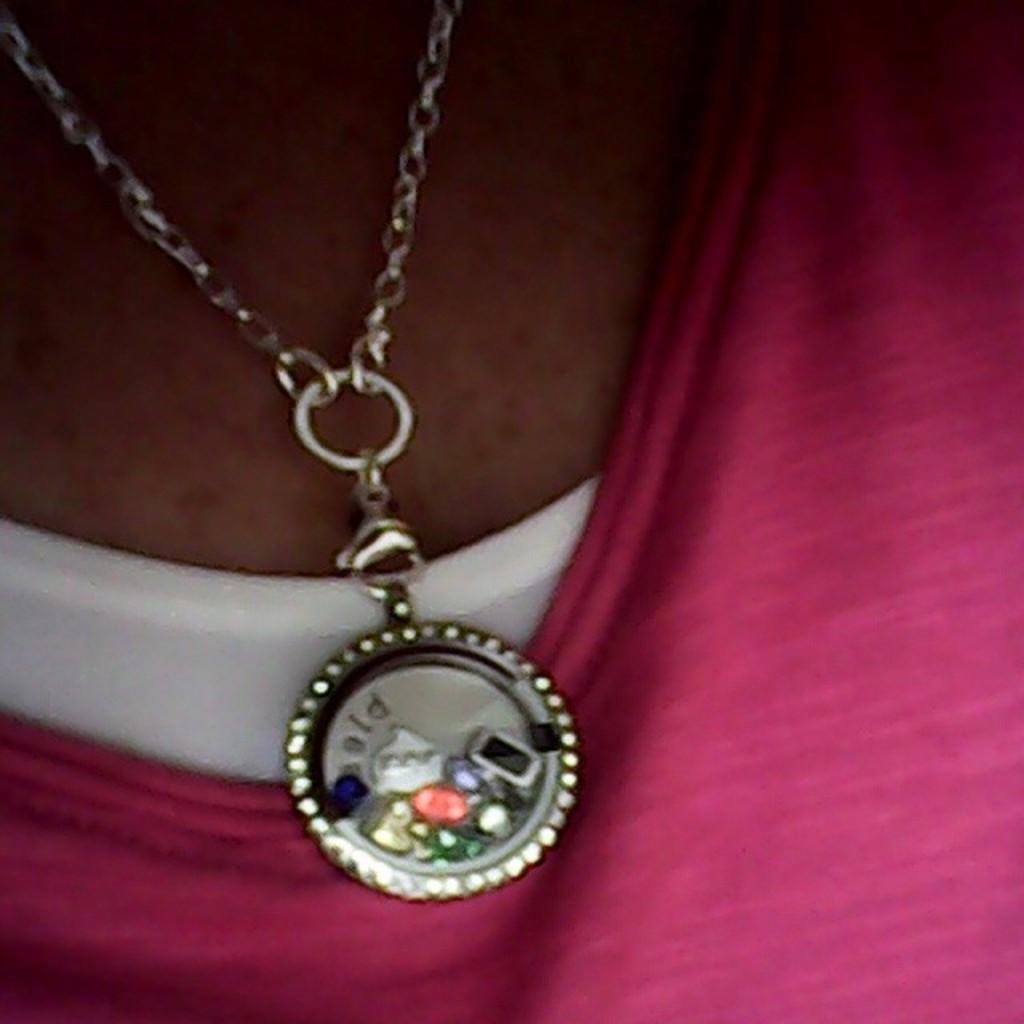Describe this image in one or two sentences. In this image I can see a person wearing pink and white color dress and there is a chain with a locket around the person's neck. 